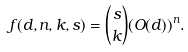Convert formula to latex. <formula><loc_0><loc_0><loc_500><loc_500>f ( d , n , k , s ) = { s \choose k } ( O ( d ) ) ^ { n } .</formula> 